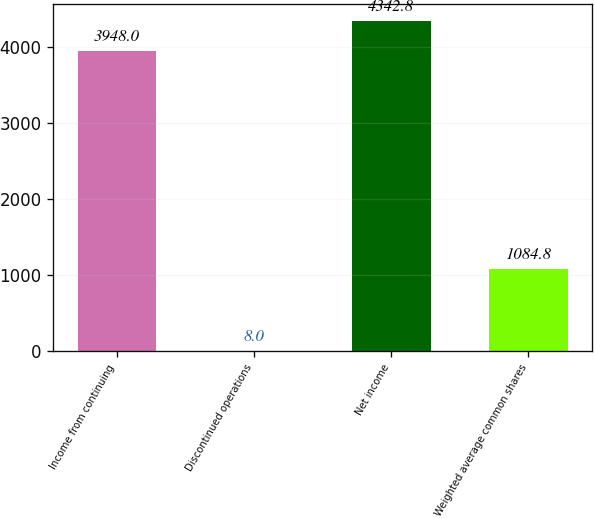Convert chart. <chart><loc_0><loc_0><loc_500><loc_500><bar_chart><fcel>Income from continuing<fcel>Discontinued operations<fcel>Net income<fcel>Weighted average common shares<nl><fcel>3948<fcel>8<fcel>4342.8<fcel>1084.8<nl></chart> 